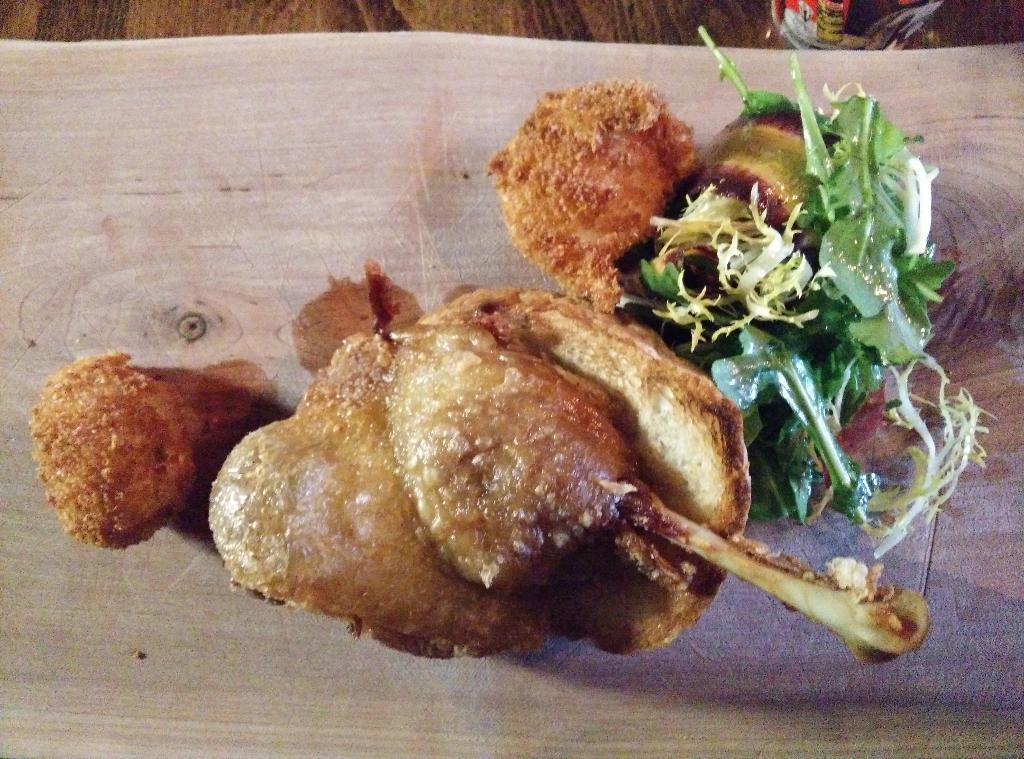What is placed on the table in the image? There is meat placed on a table in the image. What type of pest can be seen crawling on the meat in the image? There is no pest present on the meat in the image. Where is the crib located in the image? There is no crib present in the image. 